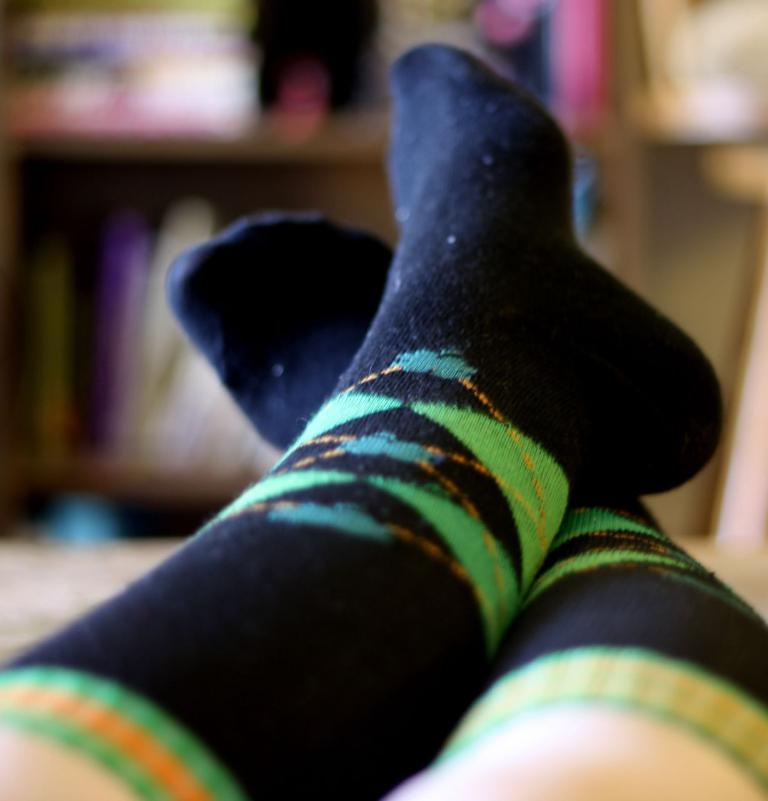What part of a person can be seen in the image? There are legs of a person visible in the image. What type of clothing is the person wearing on their feet? The person is wearing black color socks. How would you describe the quality of the image in the background? The image is blurry in the background. What type of business is being conducted in the image? There is no indication of any business activity in the image, as it only shows a person's legs and black socks. What type of sail can be seen in the image? There is no sail present in the image. 